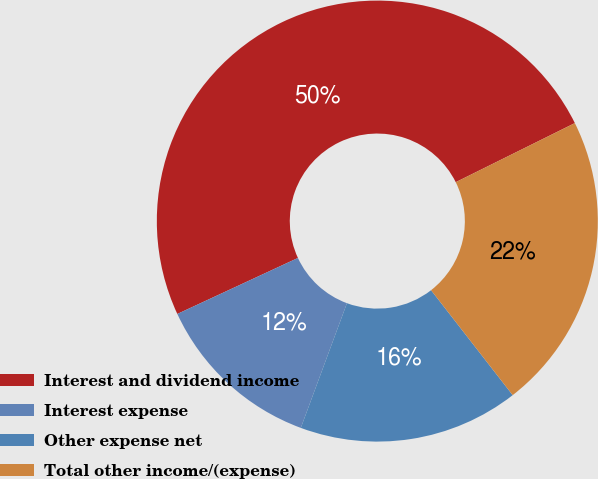Convert chart. <chart><loc_0><loc_0><loc_500><loc_500><pie_chart><fcel>Interest and dividend income<fcel>Interest expense<fcel>Other expense net<fcel>Total other income/(expense)<nl><fcel>49.59%<fcel>12.44%<fcel>16.16%<fcel>21.81%<nl></chart> 